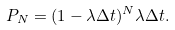Convert formula to latex. <formula><loc_0><loc_0><loc_500><loc_500>P _ { N } = ( 1 - \lambda \Delta t ) ^ { N } \lambda \Delta t .</formula> 